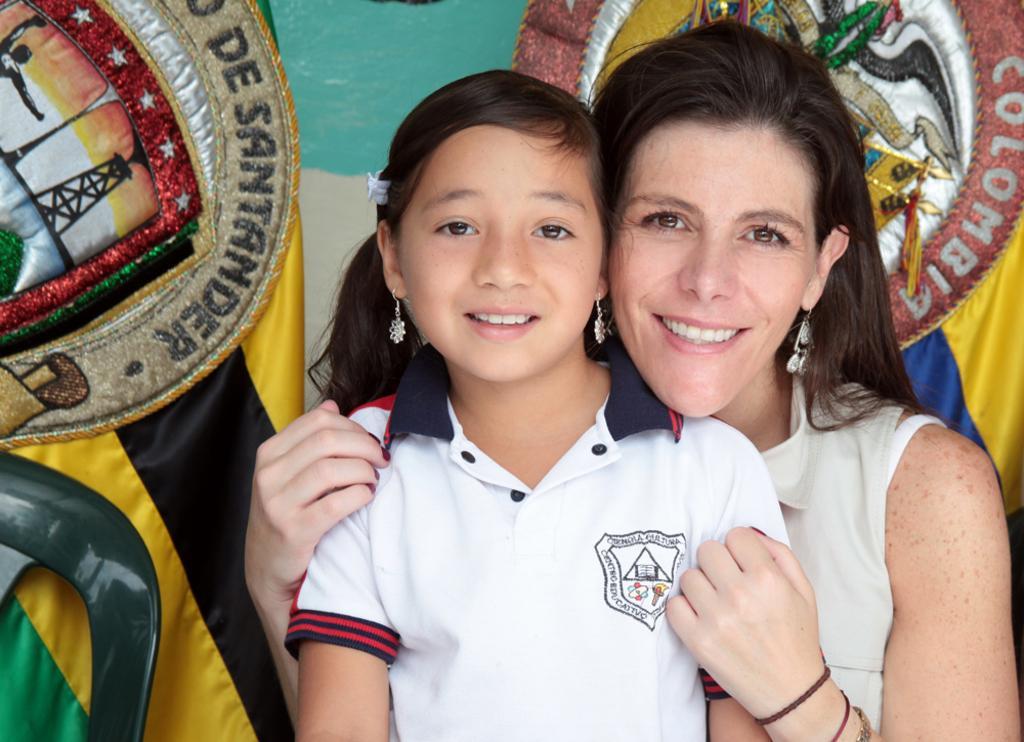Describe this image in one or two sentences. In this image we can see a woman wearing white dress and child wearing white color T-shirt are smiling. In the background, we can see few objects. 